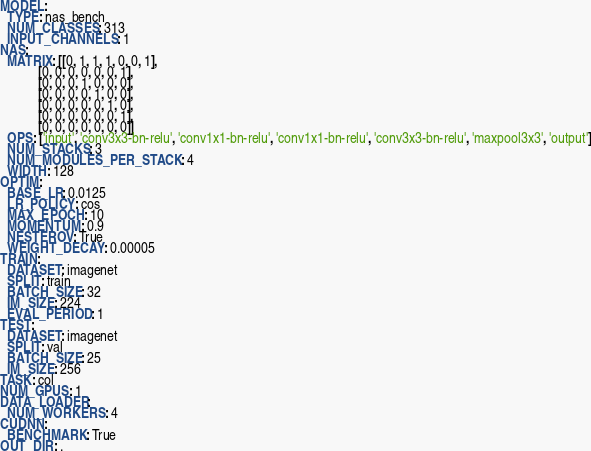<code> <loc_0><loc_0><loc_500><loc_500><_YAML_>MODEL:
  TYPE: nas_bench
  NUM_CLASSES: 313
  INPUT_CHANNELS: 1
NAS:
  MATRIX: [[0, 1, 1, 1, 0, 0, 1],
           [0, 0, 0, 0, 0, 0, 1],
           [0, 0, 0, 1, 0, 0, 0],
           [0, 0, 0, 0, 1, 0, 0],
           [0, 0, 0, 0, 0, 1, 0],
           [0, 0, 0, 0, 0, 0, 1],
           [0, 0, 0, 0, 0, 0, 0]]
  OPS: ['input', 'conv3x3-bn-relu', 'conv1x1-bn-relu', 'conv1x1-bn-relu', 'conv3x3-bn-relu', 'maxpool3x3', 'output']
  NUM_STACKS: 3
  NUM_MODULES_PER_STACK: 4
  WIDTH: 128
OPTIM:
  BASE_LR: 0.0125
  LR_POLICY: cos
  MAX_EPOCH: 10
  MOMENTUM: 0.9
  NESTEROV: True
  WEIGHT_DECAY: 0.00005
TRAIN:
  DATASET: imagenet
  SPLIT: train
  BATCH_SIZE: 32
  IM_SIZE: 224
  EVAL_PERIOD: 1
TEST:
  DATASET: imagenet
  SPLIT: val
  BATCH_SIZE: 25
  IM_SIZE: 256
TASK: col
NUM_GPUS: 1
DATA_LOADER:
  NUM_WORKERS: 4
CUDNN:
  BENCHMARK: True
OUT_DIR: .
</code> 